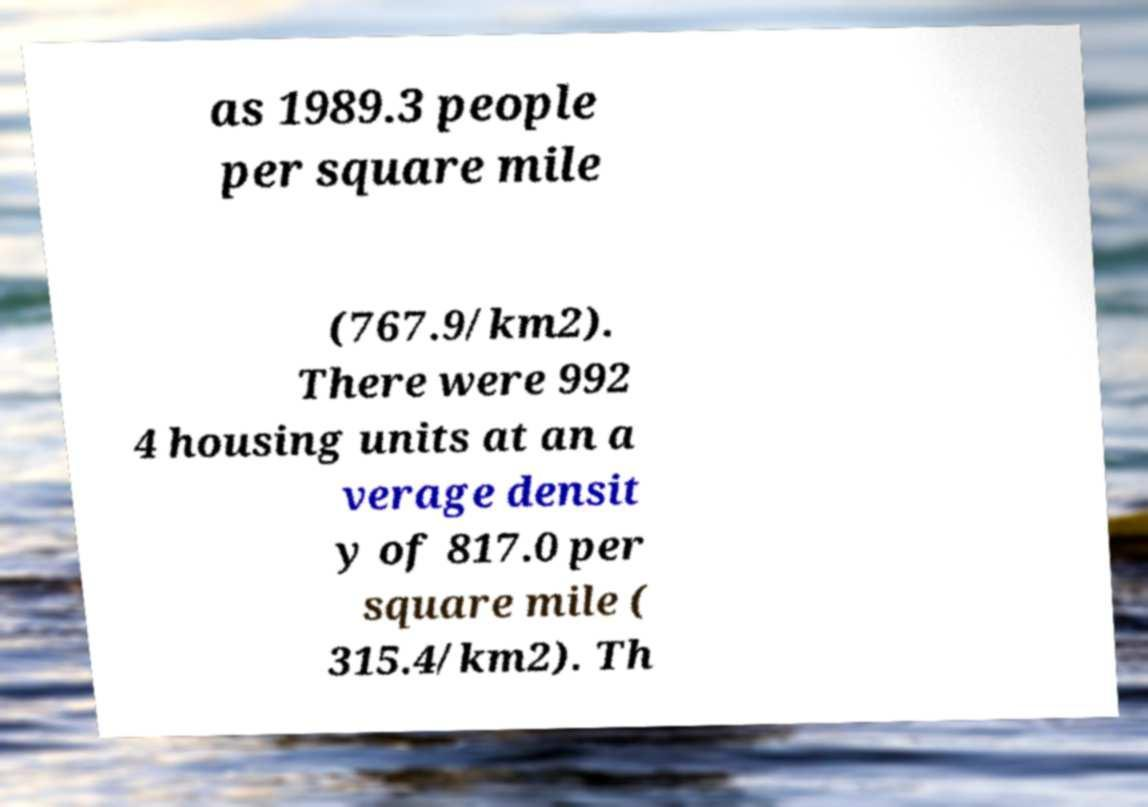Please identify and transcribe the text found in this image. as 1989.3 people per square mile (767.9/km2). There were 992 4 housing units at an a verage densit y of 817.0 per square mile ( 315.4/km2). Th 